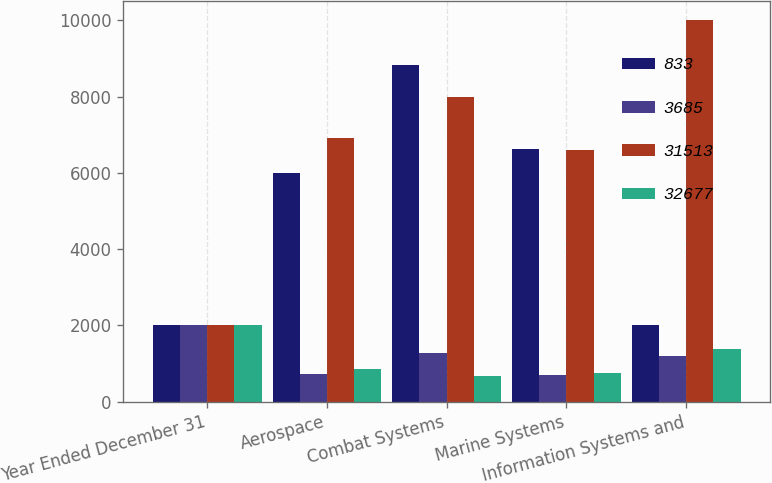Convert chart to OTSL. <chart><loc_0><loc_0><loc_500><loc_500><stacked_bar_chart><ecel><fcel>Year Ended December 31<fcel>Aerospace<fcel>Combat Systems<fcel>Marine Systems<fcel>Information Systems and<nl><fcel>833<fcel>2011<fcel>5998<fcel>8827<fcel>6631<fcel>2011<nl><fcel>3685<fcel>2011<fcel>729<fcel>1283<fcel>691<fcel>1200<nl><fcel>31513<fcel>2012<fcel>6912<fcel>7992<fcel>6592<fcel>10017<nl><fcel>32677<fcel>2012<fcel>858<fcel>663<fcel>750<fcel>1369<nl></chart> 